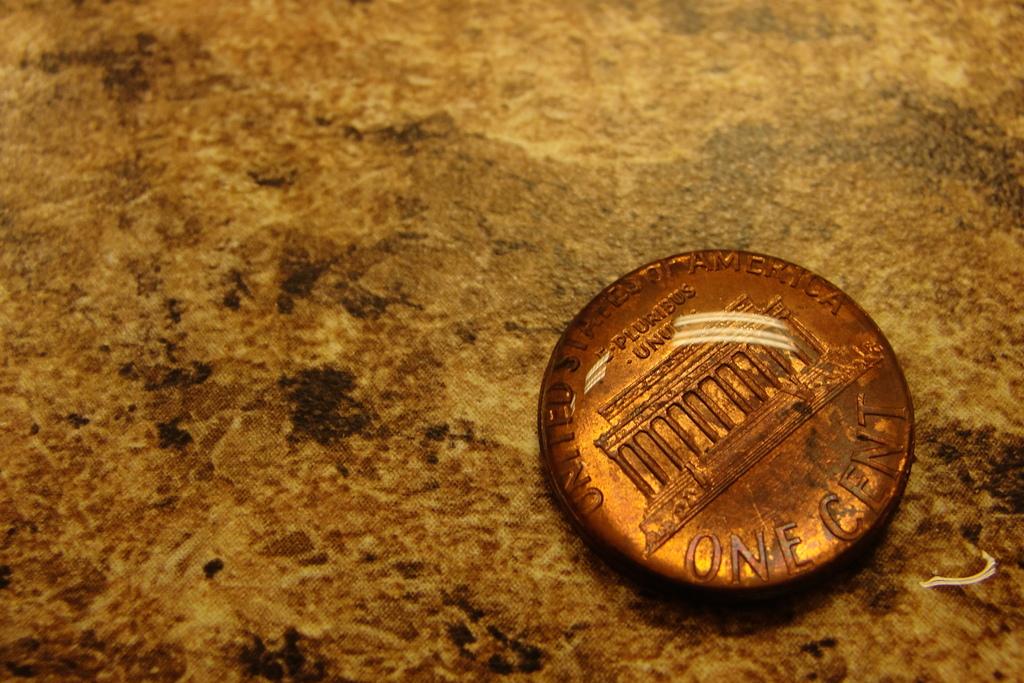How much is this coin?
Keep it short and to the point. One cent. What country is this coin from?
Make the answer very short. United states of america. 